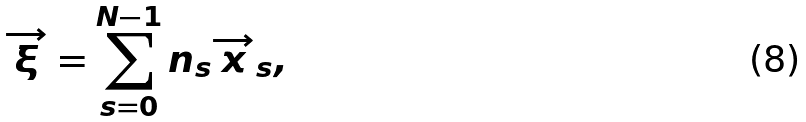Convert formula to latex. <formula><loc_0><loc_0><loc_500><loc_500>\overrightarrow { \xi } = \sum _ { s = 0 } ^ { N - 1 } n _ { s } \overrightarrow { x } _ { s } ,</formula> 